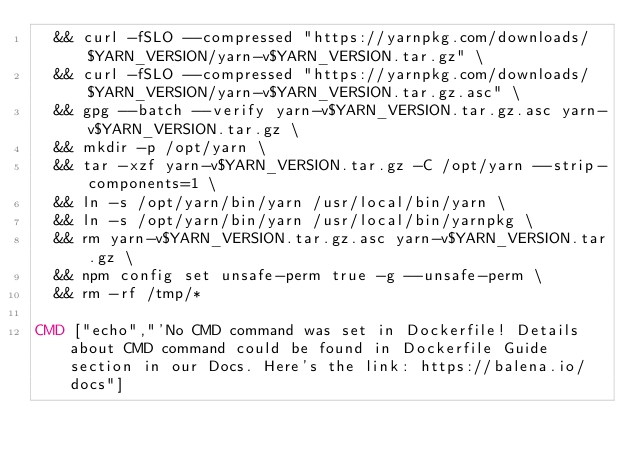<code> <loc_0><loc_0><loc_500><loc_500><_Dockerfile_>	&& curl -fSLO --compressed "https://yarnpkg.com/downloads/$YARN_VERSION/yarn-v$YARN_VERSION.tar.gz" \
	&& curl -fSLO --compressed "https://yarnpkg.com/downloads/$YARN_VERSION/yarn-v$YARN_VERSION.tar.gz.asc" \
	&& gpg --batch --verify yarn-v$YARN_VERSION.tar.gz.asc yarn-v$YARN_VERSION.tar.gz \
	&& mkdir -p /opt/yarn \
	&& tar -xzf yarn-v$YARN_VERSION.tar.gz -C /opt/yarn --strip-components=1 \
	&& ln -s /opt/yarn/bin/yarn /usr/local/bin/yarn \
	&& ln -s /opt/yarn/bin/yarn /usr/local/bin/yarnpkg \
	&& rm yarn-v$YARN_VERSION.tar.gz.asc yarn-v$YARN_VERSION.tar.gz \
	&& npm config set unsafe-perm true -g --unsafe-perm \
	&& rm -rf /tmp/*

CMD ["echo","'No CMD command was set in Dockerfile! Details about CMD command could be found in Dockerfile Guide section in our Docs. Here's the link: https://balena.io/docs"]</code> 